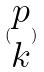<formula> <loc_0><loc_0><loc_500><loc_500>( \begin{matrix} p \\ k \end{matrix} )</formula> 